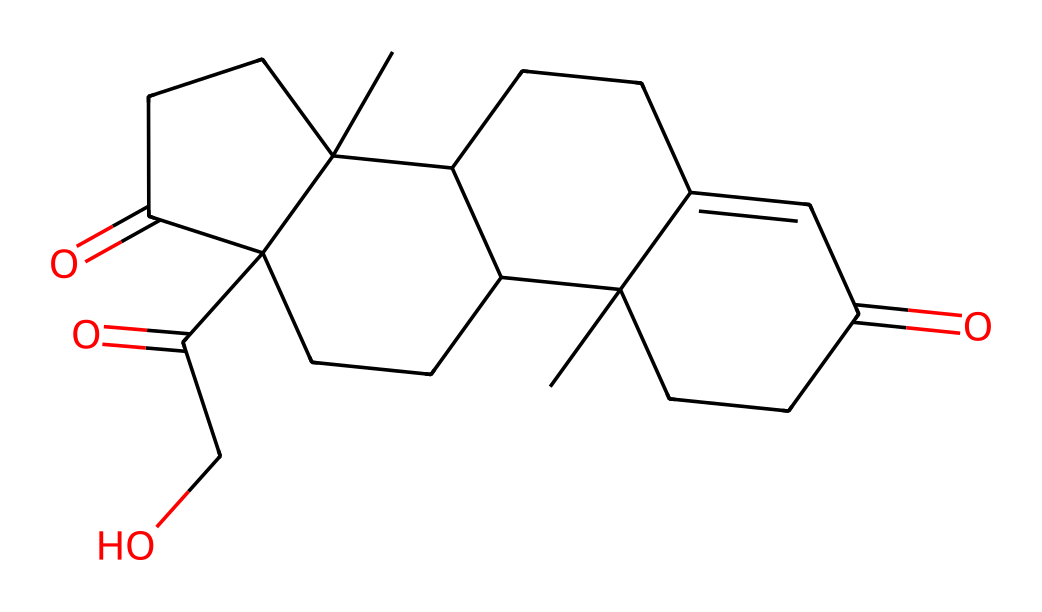How many carbon atoms are in this chemical structure? The displayed SMILES representation includes multiple carbon atoms. By counting each carbon (C) present in the structure, we find a total of 21 carbon atoms.
Answer: 21 What type of functional groups are present in cortisol? In the SMILES representation, we can identify carbonyl groups (C=O) as well as hydroxyl groups (-OH) based on the presence of oxygen atoms connected to carbon with a double bond or bonded with a hydrogen respectively. This indicates functional groups commonly associated with ketones and alcohols.
Answer: carbonyl and hydroxyl Which type of hormone is cortisol classified as? Cortisol is a steroid hormone, indicated by its structure which contains multiple fused ring systems typical of steroid molecules. The distinctive arrangement of the carbon skeleton along with functional groups categorizes it as a steroid.
Answer: steroid How many rings are present in the cortisol structure? The structure of cortisol shows a complex fused ring system. By analyzing the skeleton of the molecule and identifying the rings, we can determine that there are four fused rings present in the structure.
Answer: 4 What is the molecular weight of cortisol? To calculate the molecular weight, we consider the number of each type of atom in the molecule (21 carbon, 30 hydrogen, and 5 oxygen) and use their respective atomic weights. Summing the total gives a molecular weight of approximately 362.5 g/mol.
Answer: 362.5 g/mol 